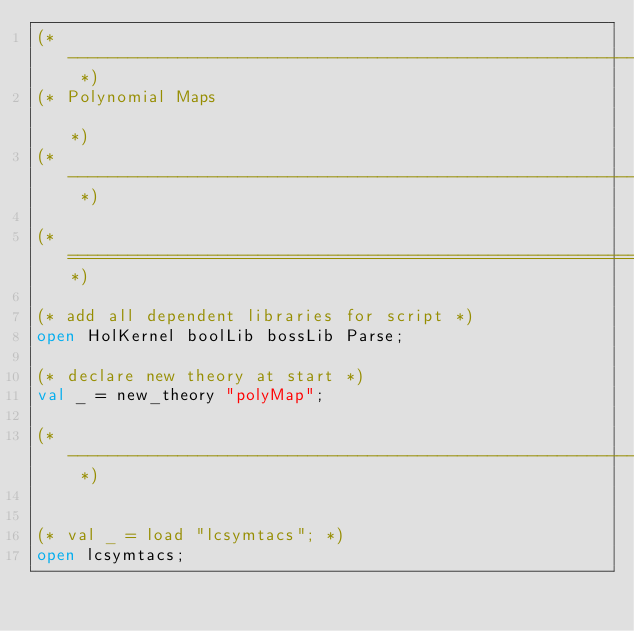<code> <loc_0><loc_0><loc_500><loc_500><_SML_>(* ------------------------------------------------------------------------ *)
(* Polynomial Maps                                                          *)
(* ------------------------------------------------------------------------ *)

(*===========================================================================*)

(* add all dependent libraries for script *)
open HolKernel boolLib bossLib Parse;

(* declare new theory at start *)
val _ = new_theory "polyMap";

(* ------------------------------------------------------------------------- *)


(* val _ = load "lcsymtacs"; *)
open lcsymtacs;
</code> 